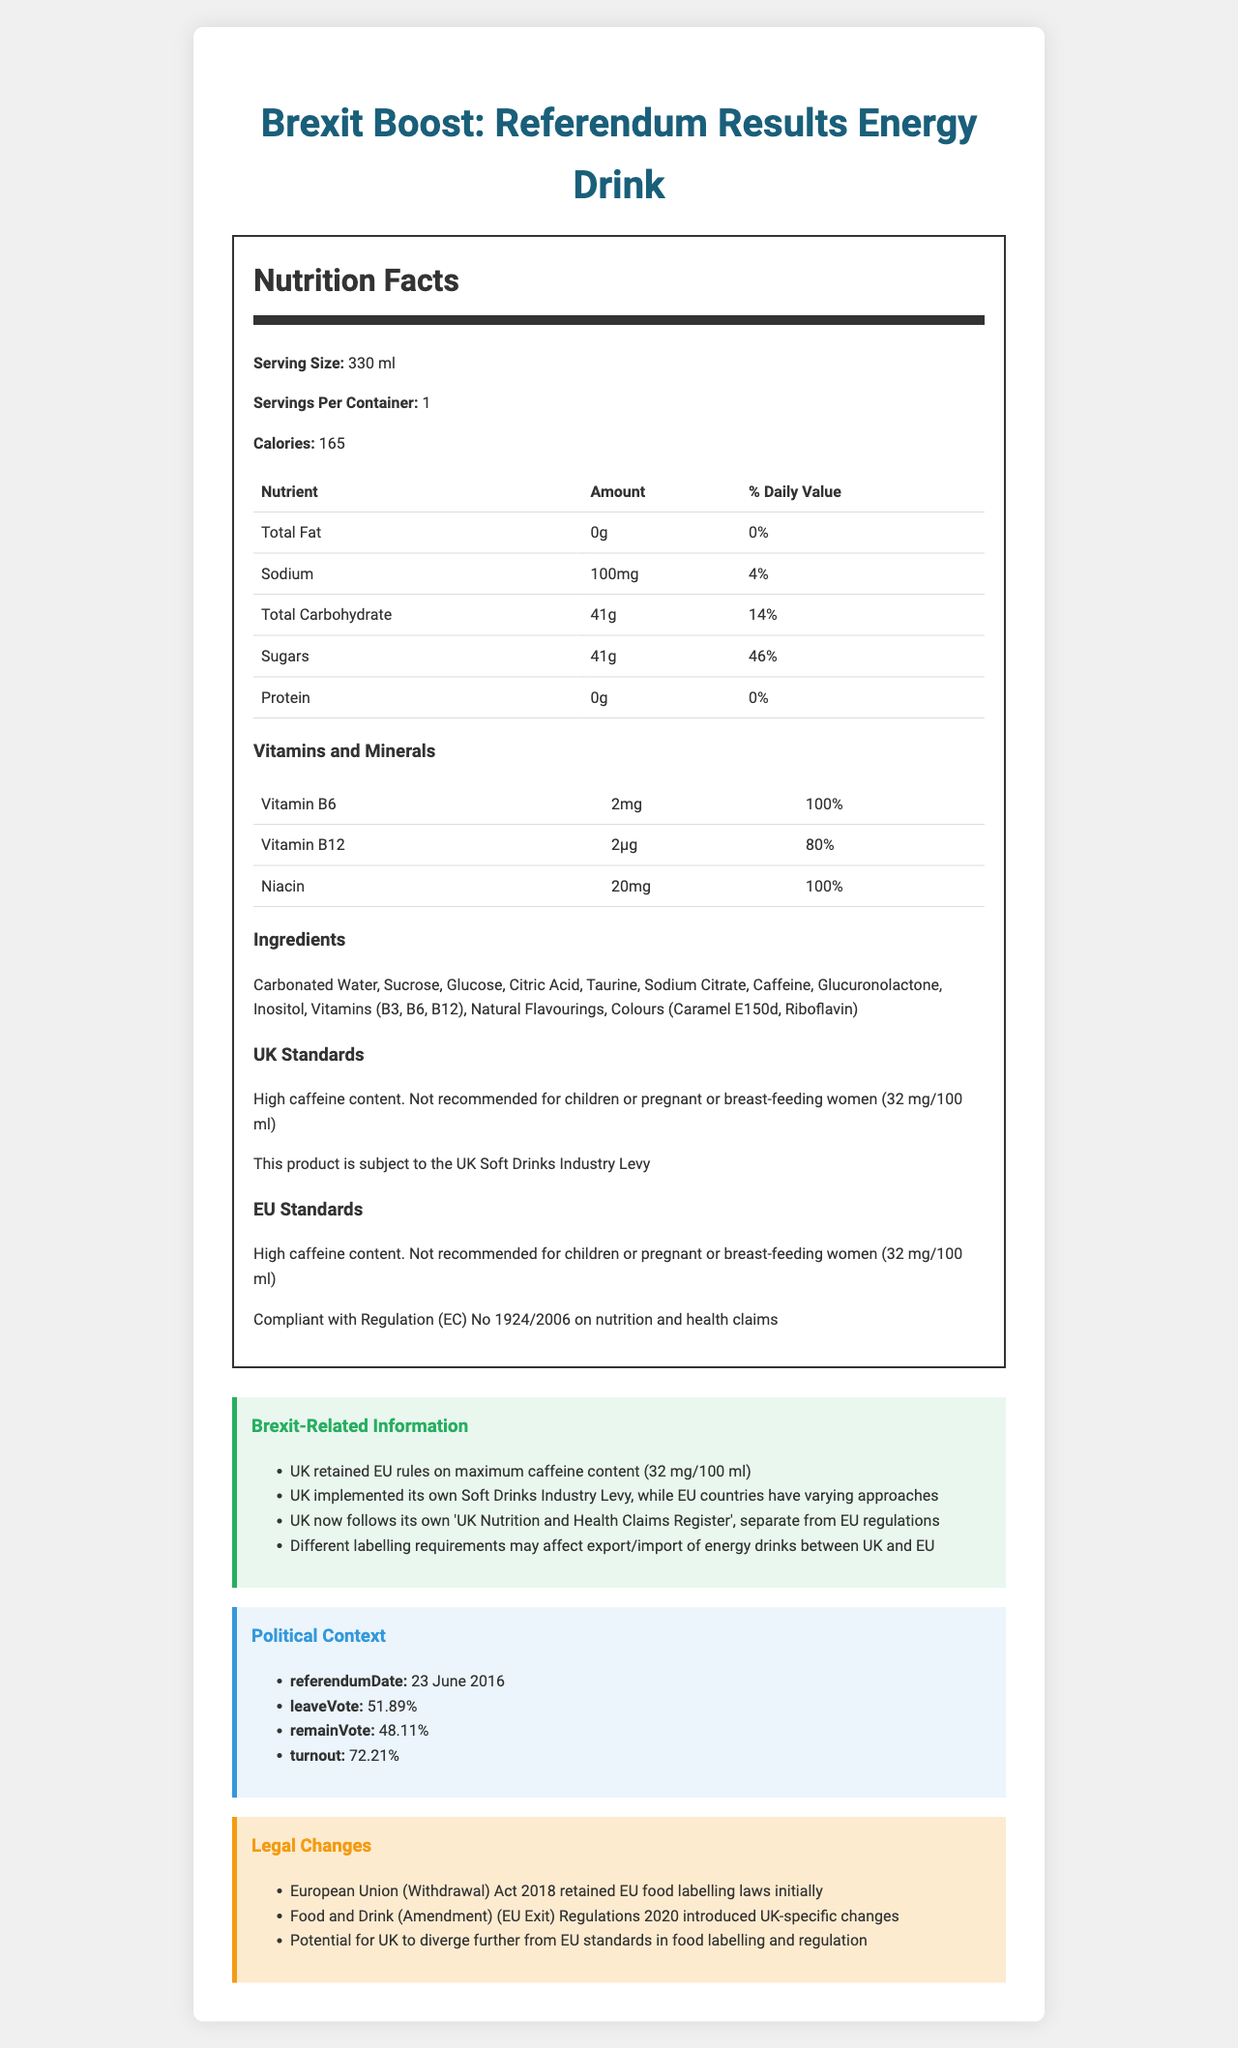what is the serving size of "Brexit Boost: Referendum Results Energy Drink"? The document specifies that the serving size is 330 ml.
Answer: 330 ml how many calories are in one serving of the energy drink? The document states there are 165 calories per serving.
Answer: 165 what is the percentage daily value of sugars in one serving? According to the document, one serving contains 41g of sugars, which is 46% of the daily value.
Answer: 46% list all the ingredients in "Brexit Boost: Referendum Results Energy Drink". The document provides a list of ingredients under the section titled "Ingredients".
Answer: Carbonated Water, Sucrose, Glucose, Citric Acid, Taurine, Sodium Citrate, Caffeine, Glucuronolactone, Inositol, Vitamins (B3, B6, B12), Natural Flavourings, Colours (Caramel E150d, Riboflavin) what vitamins are included in the drink and their amounts per serving? The document lists the vitamins and their respective amounts in the section titled "Vitamins and Minerals".
Answer: Vitamin B6 (2mg), Vitamin B12 (2µg), Niacin (20mg) what warning is given regarding caffeine content on the UK standards? The UK standards section includes this specific caffeine warning.
Answer: High caffeine content. Not recommended for children or pregnant or breast-feeding women (32 mg/100 ml) Which regulation does the EU standards compliant with regarding nutritional claims? A. Regulation (EC) No 1924/2006 B. Regulation (EU) No 1169/2011 C. Regulation (EC) No 178/2002 D. Regulation (EC) No 541/2010 The document states that the EU standards are compliant with Regulation (EC) No 1924/2006 on nutrition and health claims.
Answer: A. Regulation (EC) No 1924/2006 What is the Brexit-related change regarding food labelling requirements? A. UK follows EU regulations B. UK follows its own 'UK Nutrition and Health Claims Register' C. UK follows US regulations D. No change in food labelling requirements The document mentions that post-Brexit, the UK follows its own 'UK Nutrition and Health Claims Register'.
Answer: B. UK follows its own 'UK Nutrition and Health Claims Register' is the product subject to the UK Soft Drinks Industry Levy? The UK standards section states that the product is subject to the UK Soft Drinks Industry Levy.
Answer: Yes describe the political context of the EU referendum provided in the document. The political context section details important information about the EU referendum date, voting percentages, and voter turnout.
Answer: The political context includes the referendum date (23 June 2016), the leave vote percentage (51.89%), the remain vote percentage (48.11%), and the voter turnout (72.21%). what is the turnout percentage for the EU referendum as mentioned in the document? The document specifies that the voter turnout for the EU referendum was 72.21%.
Answer: 72.21% how has the UK dealt with EU food labelling laws post-Brexit? The legal changes section outlines that the UK initially retained EU food labelling laws and later introduced UK-specific changes.
Answer: Initially retained EU food labelling laws through the European Union (Withdrawal) Act 2018; introduced UK-specific changes through the Food and Drink (Amendment) (EU Exit) Regulations 2020. What is the potential future direction for UK's food labelling and regulation post-Brexit? The document mentions that there is potential for the UK to diverge further from EU standards in food labelling and regulation in the future.
Answer: Potential for UK to diverge further from EU standards in food labelling and regulation. does the document state whether the sugar content in the energy drink is taxed differently in the EU? The document only mentions that the UK has implemented its own Soft Drinks Industry Levy and indicates EU countries have varying approaches but does not detail the EU's approach specifically.
Answer: No, the document does not specify the EU's approach to the sugar content tax. what is the caffeine limit for energy drinks in the UK and EU as per the document? The document notes that the UK retained EU rules on maximum caffeine content, which is 32 mg/100 ml.
Answer: 32 mg/100 ml 